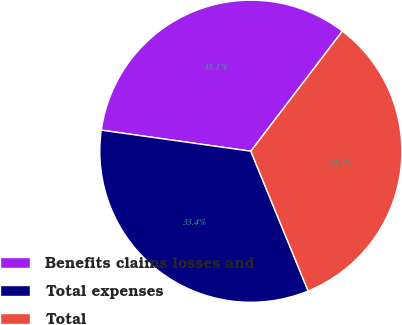<chart> <loc_0><loc_0><loc_500><loc_500><pie_chart><fcel>Benefits claims losses and<fcel>Total expenses<fcel>Total<nl><fcel>33.14%<fcel>33.42%<fcel>33.44%<nl></chart> 